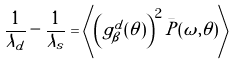<formula> <loc_0><loc_0><loc_500><loc_500>\frac { 1 } { \lambda _ { d } } - \frac { 1 } { \tilde { \lambda } _ { s } } = \left \langle \left ( g ^ { d } _ { \beta } ( \theta ) \right ) ^ { 2 } \bar { P } ( \omega , \theta ) \right \rangle</formula> 